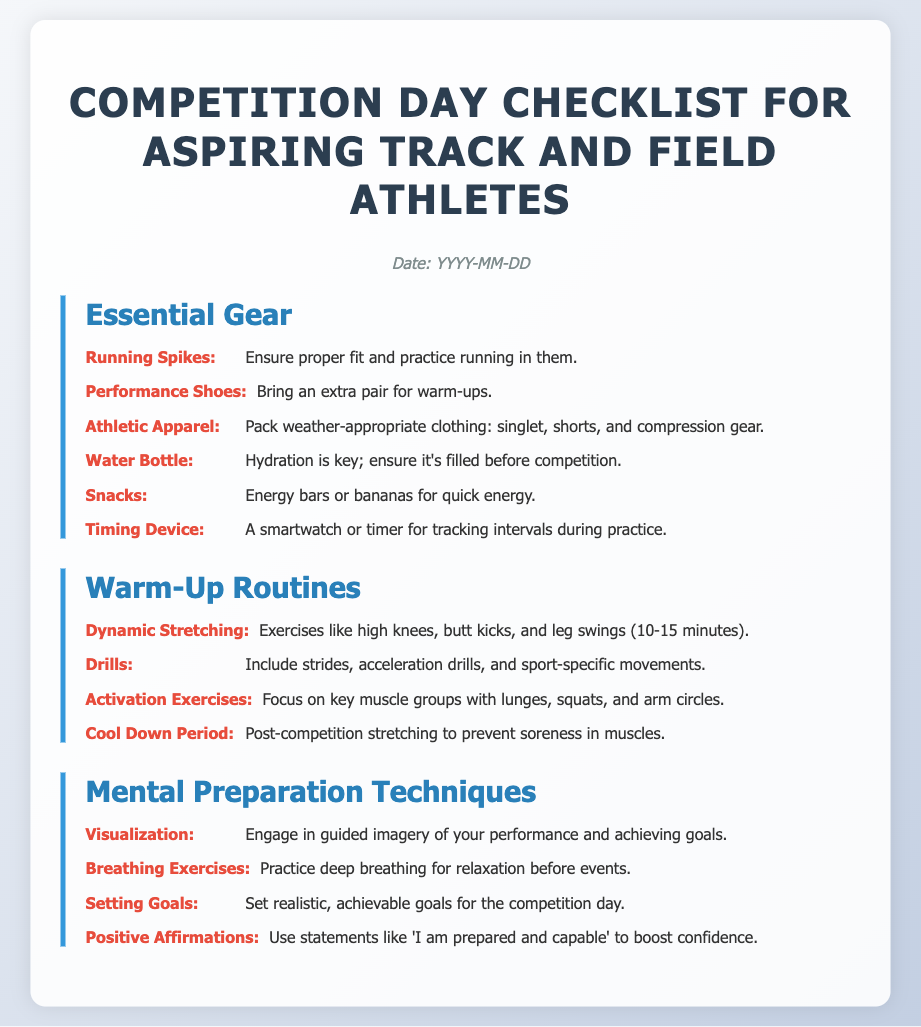What is the date for the competition day? The date is specified as a placeholder "YYYY-MM-DD" in the document.
Answer: YYYY-MM-DD What should you bring for hydration? The document lists a "Water Bottle" as essential gear for hydration.
Answer: Water Bottle What exercises are recommended for warming up? The section on warm-up routines lists "Dynamic Stretching" as a key exercise.
Answer: Dynamic Stretching What type of gear should be worn during the competition? The document states to wear "Athletic Apparel" appropriate for the weather.
Answer: Athletic Apparel What is one mental preparation technique mentioned? The document includes "Visualization" as a technique to prepare mentally.
Answer: Visualization How long should dynamic stretching last? The document specifies that dynamic stretching should last "10-15 minutes."
Answer: 10-15 minutes What type of snacks are suggested for quick energy? The document suggests "Energy bars or bananas" as snacks for quick energy.
Answer: Energy bars or bananas What should you do after the competition to prevent soreness? The document mentions performing "Cool Down Period" stretching after the competition.
Answer: Cool Down Period What is a recommended strategy for boosting confidence? The document suggests using "Positive Affirmations" to boost confidence.
Answer: Positive Affirmations 